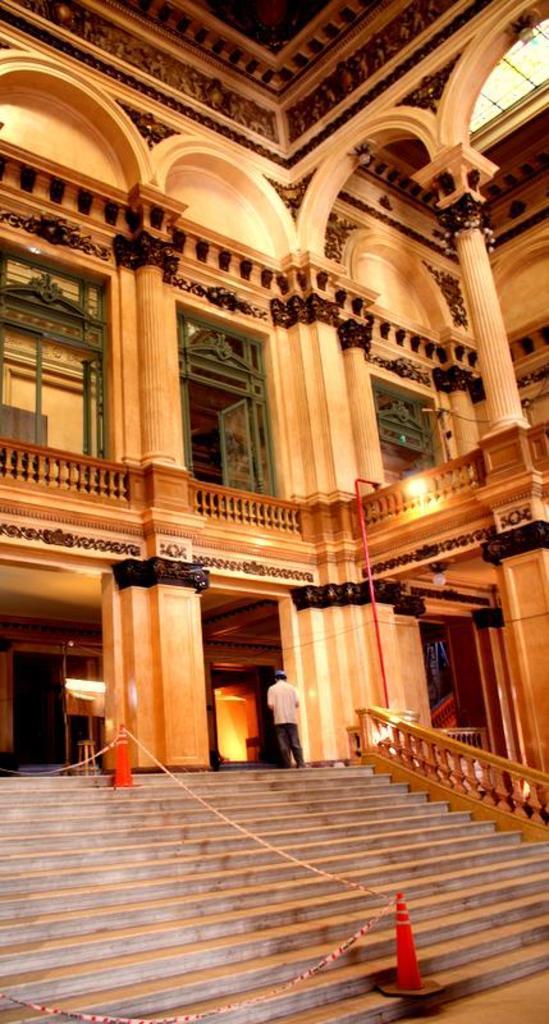In one or two sentences, can you explain what this image depicts? In this image a person is standing on the floor. Bottom of the image there is a staircase having inverted cones on it. Background there is a building having balconies. There is a door to the wall having few sculptures. 